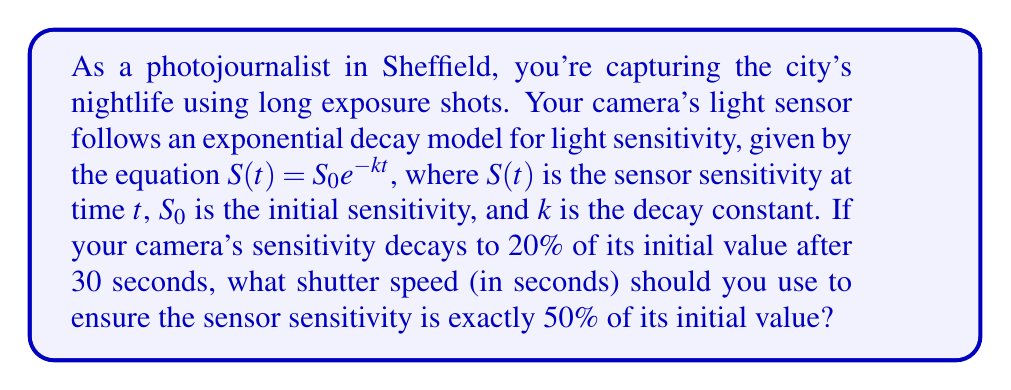Teach me how to tackle this problem. Let's approach this step-by-step:

1) We're given that the sensor sensitivity follows the exponential decay model:
   $S(t) = S_0 e^{-kt}$

2) We know that after 30 seconds, the sensitivity is 20% of the initial value:
   $0.2S_0 = S_0 e^{-k(30)}$

3) Simplify by dividing both sides by $S_0$:
   $0.2 = e^{-30k}$

4) Take the natural log of both sides:
   $\ln(0.2) = -30k$

5) Solve for $k$:
   $k = -\frac{\ln(0.2)}{30} \approx 0.0536$

6) Now, we want to find $t$ when the sensitivity is 50% of the initial value:
   $0.5S_0 = S_0 e^{-kt}$

7) Simplify:
   $0.5 = e^{-kt}$

8) Take the natural log of both sides:
   $\ln(0.5) = -kt$

9) Substitute the value of $k$ we found earlier:
   $\ln(0.5) = -0.0536t$

10) Solve for $t$:
    $t = -\frac{\ln(0.5)}{0.0536} \approx 12.93$ seconds

Therefore, the shutter speed should be set to approximately 12.93 seconds.
Answer: 12.93 seconds 